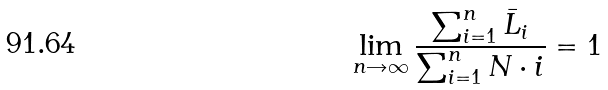Convert formula to latex. <formula><loc_0><loc_0><loc_500><loc_500>\lim _ { n \rightarrow \infty } \frac { \sum _ { i = 1 } ^ { n } \bar { L } _ { i } } { \sum _ { i = 1 } ^ { n } N \cdot i } = 1</formula> 